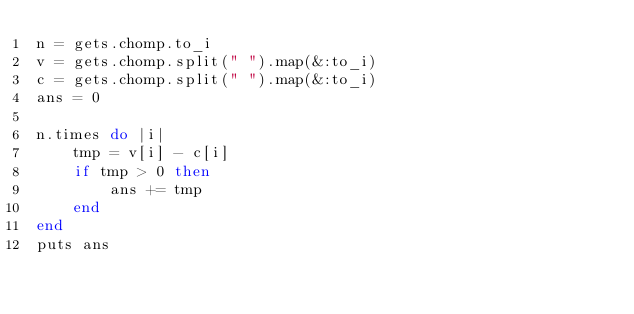Convert code to text. <code><loc_0><loc_0><loc_500><loc_500><_Ruby_>n = gets.chomp.to_i
v = gets.chomp.split(" ").map(&:to_i)
c = gets.chomp.split(" ").map(&:to_i)
ans = 0

n.times do |i|
    tmp = v[i] - c[i]
    if tmp > 0 then
        ans += tmp
    end
end
puts ans</code> 